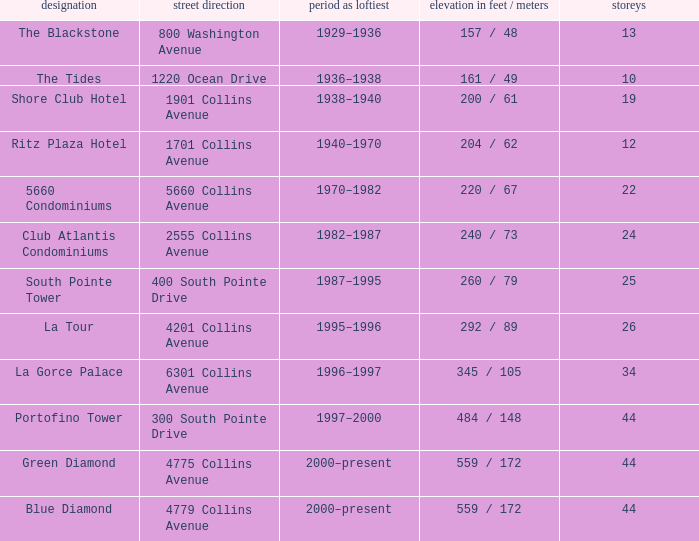How many floors does the Blue Diamond have? 44.0. 